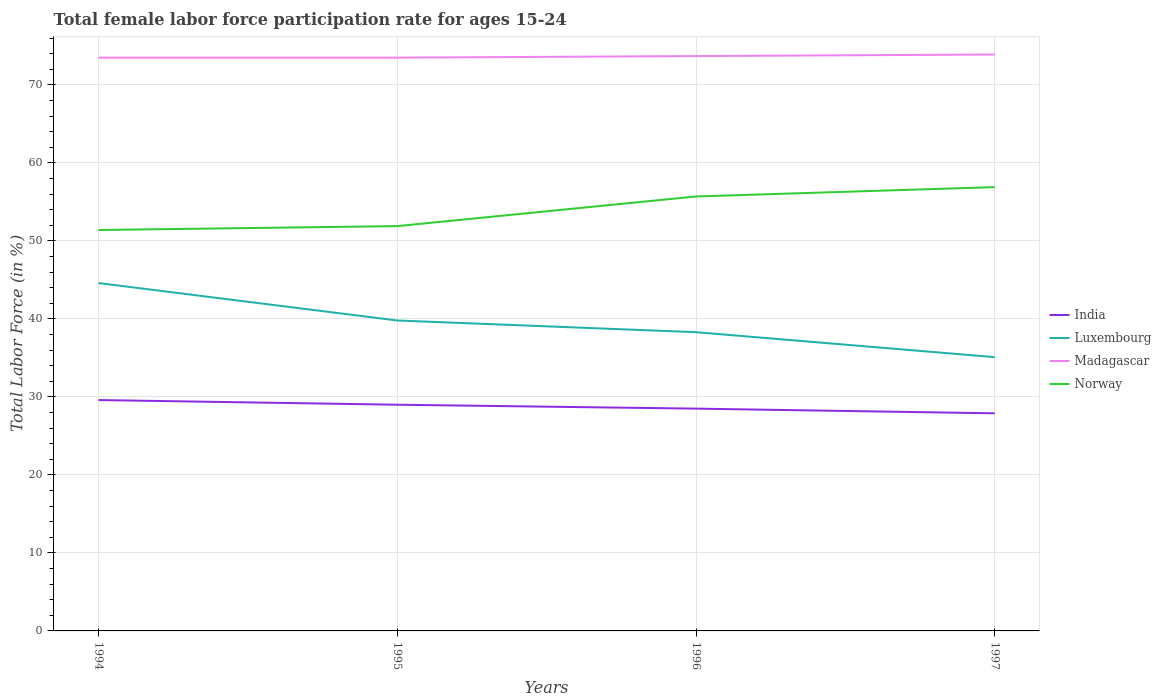Is the number of lines equal to the number of legend labels?
Give a very brief answer. Yes. Across all years, what is the maximum female labor force participation rate in Madagascar?
Offer a very short reply. 73.5. What is the total female labor force participation rate in Madagascar in the graph?
Provide a short and direct response. -0.4. Is the female labor force participation rate in Madagascar strictly greater than the female labor force participation rate in Norway over the years?
Offer a terse response. No. How many lines are there?
Offer a very short reply. 4. How many legend labels are there?
Provide a short and direct response. 4. How are the legend labels stacked?
Ensure brevity in your answer.  Vertical. What is the title of the graph?
Your answer should be compact. Total female labor force participation rate for ages 15-24. Does "Senegal" appear as one of the legend labels in the graph?
Provide a short and direct response. No. What is the label or title of the Y-axis?
Your answer should be very brief. Total Labor Force (in %). What is the Total Labor Force (in %) in India in 1994?
Offer a very short reply. 29.6. What is the Total Labor Force (in %) in Luxembourg in 1994?
Offer a very short reply. 44.6. What is the Total Labor Force (in %) of Madagascar in 1994?
Offer a terse response. 73.5. What is the Total Labor Force (in %) of Norway in 1994?
Offer a very short reply. 51.4. What is the Total Labor Force (in %) in India in 1995?
Ensure brevity in your answer.  29. What is the Total Labor Force (in %) of Luxembourg in 1995?
Offer a very short reply. 39.8. What is the Total Labor Force (in %) of Madagascar in 1995?
Make the answer very short. 73.5. What is the Total Labor Force (in %) in Norway in 1995?
Your response must be concise. 51.9. What is the Total Labor Force (in %) of Luxembourg in 1996?
Your answer should be very brief. 38.3. What is the Total Labor Force (in %) of Madagascar in 1996?
Make the answer very short. 73.7. What is the Total Labor Force (in %) of Norway in 1996?
Provide a succinct answer. 55.7. What is the Total Labor Force (in %) of India in 1997?
Provide a short and direct response. 27.9. What is the Total Labor Force (in %) of Luxembourg in 1997?
Your answer should be compact. 35.1. What is the Total Labor Force (in %) of Madagascar in 1997?
Your answer should be compact. 73.9. What is the Total Labor Force (in %) of Norway in 1997?
Provide a short and direct response. 56.9. Across all years, what is the maximum Total Labor Force (in %) in India?
Offer a very short reply. 29.6. Across all years, what is the maximum Total Labor Force (in %) of Luxembourg?
Make the answer very short. 44.6. Across all years, what is the maximum Total Labor Force (in %) of Madagascar?
Make the answer very short. 73.9. Across all years, what is the maximum Total Labor Force (in %) of Norway?
Provide a succinct answer. 56.9. Across all years, what is the minimum Total Labor Force (in %) of India?
Ensure brevity in your answer.  27.9. Across all years, what is the minimum Total Labor Force (in %) in Luxembourg?
Offer a very short reply. 35.1. Across all years, what is the minimum Total Labor Force (in %) of Madagascar?
Give a very brief answer. 73.5. Across all years, what is the minimum Total Labor Force (in %) of Norway?
Ensure brevity in your answer.  51.4. What is the total Total Labor Force (in %) of India in the graph?
Keep it short and to the point. 115. What is the total Total Labor Force (in %) of Luxembourg in the graph?
Provide a short and direct response. 157.8. What is the total Total Labor Force (in %) in Madagascar in the graph?
Offer a terse response. 294.6. What is the total Total Labor Force (in %) in Norway in the graph?
Give a very brief answer. 215.9. What is the difference between the Total Labor Force (in %) in India in 1994 and that in 1995?
Your answer should be compact. 0.6. What is the difference between the Total Labor Force (in %) in Luxembourg in 1994 and that in 1995?
Provide a succinct answer. 4.8. What is the difference between the Total Labor Force (in %) in Madagascar in 1994 and that in 1995?
Ensure brevity in your answer.  0. What is the difference between the Total Labor Force (in %) of Norway in 1994 and that in 1995?
Make the answer very short. -0.5. What is the difference between the Total Labor Force (in %) in India in 1994 and that in 1996?
Your answer should be compact. 1.1. What is the difference between the Total Labor Force (in %) of India in 1994 and that in 1997?
Provide a succinct answer. 1.7. What is the difference between the Total Labor Force (in %) in Luxembourg in 1994 and that in 1997?
Make the answer very short. 9.5. What is the difference between the Total Labor Force (in %) of Norway in 1994 and that in 1997?
Your response must be concise. -5.5. What is the difference between the Total Labor Force (in %) in India in 1995 and that in 1996?
Your answer should be compact. 0.5. What is the difference between the Total Labor Force (in %) in Luxembourg in 1995 and that in 1996?
Provide a succinct answer. 1.5. What is the difference between the Total Labor Force (in %) in Madagascar in 1995 and that in 1996?
Provide a short and direct response. -0.2. What is the difference between the Total Labor Force (in %) of Norway in 1995 and that in 1996?
Your answer should be very brief. -3.8. What is the difference between the Total Labor Force (in %) in Luxembourg in 1995 and that in 1997?
Your answer should be very brief. 4.7. What is the difference between the Total Labor Force (in %) in Madagascar in 1995 and that in 1997?
Give a very brief answer. -0.4. What is the difference between the Total Labor Force (in %) in India in 1996 and that in 1997?
Your answer should be very brief. 0.6. What is the difference between the Total Labor Force (in %) in Madagascar in 1996 and that in 1997?
Your response must be concise. -0.2. What is the difference between the Total Labor Force (in %) of Norway in 1996 and that in 1997?
Give a very brief answer. -1.2. What is the difference between the Total Labor Force (in %) in India in 1994 and the Total Labor Force (in %) in Luxembourg in 1995?
Offer a terse response. -10.2. What is the difference between the Total Labor Force (in %) of India in 1994 and the Total Labor Force (in %) of Madagascar in 1995?
Give a very brief answer. -43.9. What is the difference between the Total Labor Force (in %) in India in 1994 and the Total Labor Force (in %) in Norway in 1995?
Offer a terse response. -22.3. What is the difference between the Total Labor Force (in %) in Luxembourg in 1994 and the Total Labor Force (in %) in Madagascar in 1995?
Keep it short and to the point. -28.9. What is the difference between the Total Labor Force (in %) of Madagascar in 1994 and the Total Labor Force (in %) of Norway in 1995?
Offer a terse response. 21.6. What is the difference between the Total Labor Force (in %) of India in 1994 and the Total Labor Force (in %) of Madagascar in 1996?
Make the answer very short. -44.1. What is the difference between the Total Labor Force (in %) in India in 1994 and the Total Labor Force (in %) in Norway in 1996?
Offer a terse response. -26.1. What is the difference between the Total Labor Force (in %) of Luxembourg in 1994 and the Total Labor Force (in %) of Madagascar in 1996?
Your response must be concise. -29.1. What is the difference between the Total Labor Force (in %) in Madagascar in 1994 and the Total Labor Force (in %) in Norway in 1996?
Ensure brevity in your answer.  17.8. What is the difference between the Total Labor Force (in %) in India in 1994 and the Total Labor Force (in %) in Madagascar in 1997?
Provide a short and direct response. -44.3. What is the difference between the Total Labor Force (in %) in India in 1994 and the Total Labor Force (in %) in Norway in 1997?
Your response must be concise. -27.3. What is the difference between the Total Labor Force (in %) of Luxembourg in 1994 and the Total Labor Force (in %) of Madagascar in 1997?
Keep it short and to the point. -29.3. What is the difference between the Total Labor Force (in %) of Luxembourg in 1994 and the Total Labor Force (in %) of Norway in 1997?
Ensure brevity in your answer.  -12.3. What is the difference between the Total Labor Force (in %) of India in 1995 and the Total Labor Force (in %) of Luxembourg in 1996?
Offer a very short reply. -9.3. What is the difference between the Total Labor Force (in %) of India in 1995 and the Total Labor Force (in %) of Madagascar in 1996?
Your answer should be very brief. -44.7. What is the difference between the Total Labor Force (in %) in India in 1995 and the Total Labor Force (in %) in Norway in 1996?
Give a very brief answer. -26.7. What is the difference between the Total Labor Force (in %) in Luxembourg in 1995 and the Total Labor Force (in %) in Madagascar in 1996?
Offer a terse response. -33.9. What is the difference between the Total Labor Force (in %) of Luxembourg in 1995 and the Total Labor Force (in %) of Norway in 1996?
Offer a very short reply. -15.9. What is the difference between the Total Labor Force (in %) of Madagascar in 1995 and the Total Labor Force (in %) of Norway in 1996?
Provide a short and direct response. 17.8. What is the difference between the Total Labor Force (in %) in India in 1995 and the Total Labor Force (in %) in Luxembourg in 1997?
Offer a terse response. -6.1. What is the difference between the Total Labor Force (in %) in India in 1995 and the Total Labor Force (in %) in Madagascar in 1997?
Ensure brevity in your answer.  -44.9. What is the difference between the Total Labor Force (in %) of India in 1995 and the Total Labor Force (in %) of Norway in 1997?
Your response must be concise. -27.9. What is the difference between the Total Labor Force (in %) in Luxembourg in 1995 and the Total Labor Force (in %) in Madagascar in 1997?
Give a very brief answer. -34.1. What is the difference between the Total Labor Force (in %) of Luxembourg in 1995 and the Total Labor Force (in %) of Norway in 1997?
Provide a short and direct response. -17.1. What is the difference between the Total Labor Force (in %) in Madagascar in 1995 and the Total Labor Force (in %) in Norway in 1997?
Keep it short and to the point. 16.6. What is the difference between the Total Labor Force (in %) in India in 1996 and the Total Labor Force (in %) in Luxembourg in 1997?
Your response must be concise. -6.6. What is the difference between the Total Labor Force (in %) in India in 1996 and the Total Labor Force (in %) in Madagascar in 1997?
Offer a terse response. -45.4. What is the difference between the Total Labor Force (in %) in India in 1996 and the Total Labor Force (in %) in Norway in 1997?
Your response must be concise. -28.4. What is the difference between the Total Labor Force (in %) of Luxembourg in 1996 and the Total Labor Force (in %) of Madagascar in 1997?
Your answer should be very brief. -35.6. What is the difference between the Total Labor Force (in %) in Luxembourg in 1996 and the Total Labor Force (in %) in Norway in 1997?
Your answer should be very brief. -18.6. What is the average Total Labor Force (in %) of India per year?
Offer a terse response. 28.75. What is the average Total Labor Force (in %) of Luxembourg per year?
Provide a succinct answer. 39.45. What is the average Total Labor Force (in %) of Madagascar per year?
Offer a very short reply. 73.65. What is the average Total Labor Force (in %) of Norway per year?
Your response must be concise. 53.98. In the year 1994, what is the difference between the Total Labor Force (in %) in India and Total Labor Force (in %) in Madagascar?
Your response must be concise. -43.9. In the year 1994, what is the difference between the Total Labor Force (in %) in India and Total Labor Force (in %) in Norway?
Your response must be concise. -21.8. In the year 1994, what is the difference between the Total Labor Force (in %) of Luxembourg and Total Labor Force (in %) of Madagascar?
Offer a terse response. -28.9. In the year 1994, what is the difference between the Total Labor Force (in %) of Luxembourg and Total Labor Force (in %) of Norway?
Provide a succinct answer. -6.8. In the year 1994, what is the difference between the Total Labor Force (in %) in Madagascar and Total Labor Force (in %) in Norway?
Provide a short and direct response. 22.1. In the year 1995, what is the difference between the Total Labor Force (in %) in India and Total Labor Force (in %) in Madagascar?
Give a very brief answer. -44.5. In the year 1995, what is the difference between the Total Labor Force (in %) of India and Total Labor Force (in %) of Norway?
Give a very brief answer. -22.9. In the year 1995, what is the difference between the Total Labor Force (in %) of Luxembourg and Total Labor Force (in %) of Madagascar?
Offer a terse response. -33.7. In the year 1995, what is the difference between the Total Labor Force (in %) in Madagascar and Total Labor Force (in %) in Norway?
Your response must be concise. 21.6. In the year 1996, what is the difference between the Total Labor Force (in %) in India and Total Labor Force (in %) in Luxembourg?
Your response must be concise. -9.8. In the year 1996, what is the difference between the Total Labor Force (in %) in India and Total Labor Force (in %) in Madagascar?
Offer a very short reply. -45.2. In the year 1996, what is the difference between the Total Labor Force (in %) of India and Total Labor Force (in %) of Norway?
Your answer should be compact. -27.2. In the year 1996, what is the difference between the Total Labor Force (in %) in Luxembourg and Total Labor Force (in %) in Madagascar?
Your answer should be compact. -35.4. In the year 1996, what is the difference between the Total Labor Force (in %) in Luxembourg and Total Labor Force (in %) in Norway?
Ensure brevity in your answer.  -17.4. In the year 1996, what is the difference between the Total Labor Force (in %) of Madagascar and Total Labor Force (in %) of Norway?
Your response must be concise. 18. In the year 1997, what is the difference between the Total Labor Force (in %) in India and Total Labor Force (in %) in Luxembourg?
Your response must be concise. -7.2. In the year 1997, what is the difference between the Total Labor Force (in %) of India and Total Labor Force (in %) of Madagascar?
Make the answer very short. -46. In the year 1997, what is the difference between the Total Labor Force (in %) in India and Total Labor Force (in %) in Norway?
Offer a terse response. -29. In the year 1997, what is the difference between the Total Labor Force (in %) in Luxembourg and Total Labor Force (in %) in Madagascar?
Give a very brief answer. -38.8. In the year 1997, what is the difference between the Total Labor Force (in %) in Luxembourg and Total Labor Force (in %) in Norway?
Offer a terse response. -21.8. What is the ratio of the Total Labor Force (in %) in India in 1994 to that in 1995?
Give a very brief answer. 1.02. What is the ratio of the Total Labor Force (in %) in Luxembourg in 1994 to that in 1995?
Provide a short and direct response. 1.12. What is the ratio of the Total Labor Force (in %) in Madagascar in 1994 to that in 1995?
Make the answer very short. 1. What is the ratio of the Total Labor Force (in %) in India in 1994 to that in 1996?
Make the answer very short. 1.04. What is the ratio of the Total Labor Force (in %) of Luxembourg in 1994 to that in 1996?
Provide a succinct answer. 1.16. What is the ratio of the Total Labor Force (in %) of Norway in 1994 to that in 1996?
Your answer should be compact. 0.92. What is the ratio of the Total Labor Force (in %) in India in 1994 to that in 1997?
Provide a succinct answer. 1.06. What is the ratio of the Total Labor Force (in %) in Luxembourg in 1994 to that in 1997?
Your answer should be very brief. 1.27. What is the ratio of the Total Labor Force (in %) in Madagascar in 1994 to that in 1997?
Offer a very short reply. 0.99. What is the ratio of the Total Labor Force (in %) in Norway in 1994 to that in 1997?
Provide a succinct answer. 0.9. What is the ratio of the Total Labor Force (in %) in India in 1995 to that in 1996?
Your answer should be compact. 1.02. What is the ratio of the Total Labor Force (in %) of Luxembourg in 1995 to that in 1996?
Provide a short and direct response. 1.04. What is the ratio of the Total Labor Force (in %) in Norway in 1995 to that in 1996?
Give a very brief answer. 0.93. What is the ratio of the Total Labor Force (in %) of India in 1995 to that in 1997?
Provide a short and direct response. 1.04. What is the ratio of the Total Labor Force (in %) of Luxembourg in 1995 to that in 1997?
Your answer should be very brief. 1.13. What is the ratio of the Total Labor Force (in %) of Madagascar in 1995 to that in 1997?
Ensure brevity in your answer.  0.99. What is the ratio of the Total Labor Force (in %) of Norway in 1995 to that in 1997?
Ensure brevity in your answer.  0.91. What is the ratio of the Total Labor Force (in %) of India in 1996 to that in 1997?
Keep it short and to the point. 1.02. What is the ratio of the Total Labor Force (in %) in Luxembourg in 1996 to that in 1997?
Keep it short and to the point. 1.09. What is the ratio of the Total Labor Force (in %) in Madagascar in 1996 to that in 1997?
Your answer should be very brief. 1. What is the ratio of the Total Labor Force (in %) in Norway in 1996 to that in 1997?
Your answer should be very brief. 0.98. What is the difference between the highest and the second highest Total Labor Force (in %) of Luxembourg?
Keep it short and to the point. 4.8. What is the difference between the highest and the lowest Total Labor Force (in %) in India?
Make the answer very short. 1.7. What is the difference between the highest and the lowest Total Labor Force (in %) of Norway?
Your response must be concise. 5.5. 